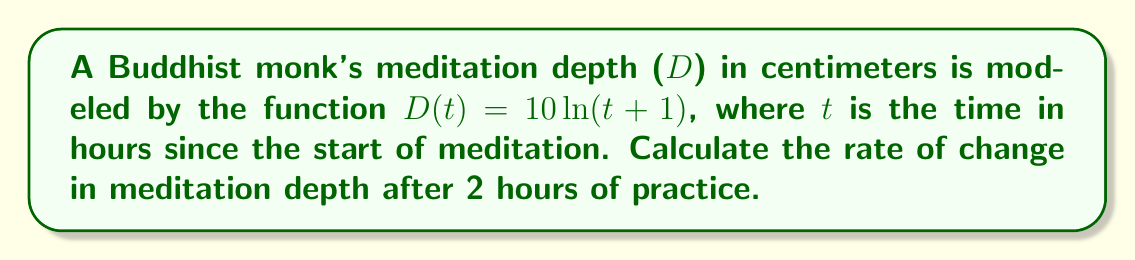Help me with this question. To find the rate of change in meditation depth at a specific time, we need to calculate the derivative of the given function and evaluate it at t = 2.

Step 1: Find the derivative of $D(t) = 10\ln(t+1)$
Using the chain rule, we get:
$$\frac{dD}{dt} = 10 \cdot \frac{d}{dt}[\ln(t+1)] = 10 \cdot \frac{1}{t+1}$$

Step 2: Evaluate the derivative at t = 2
$$\frac{dD}{dt}\Big|_{t=2} = 10 \cdot \frac{1}{2+1} = \frac{10}{3}$$

Step 3: Interpret the result
The rate of change in meditation depth after 2 hours is $\frac{10}{3}$ cm/hour.
Answer: $\frac{10}{3}$ cm/hour 